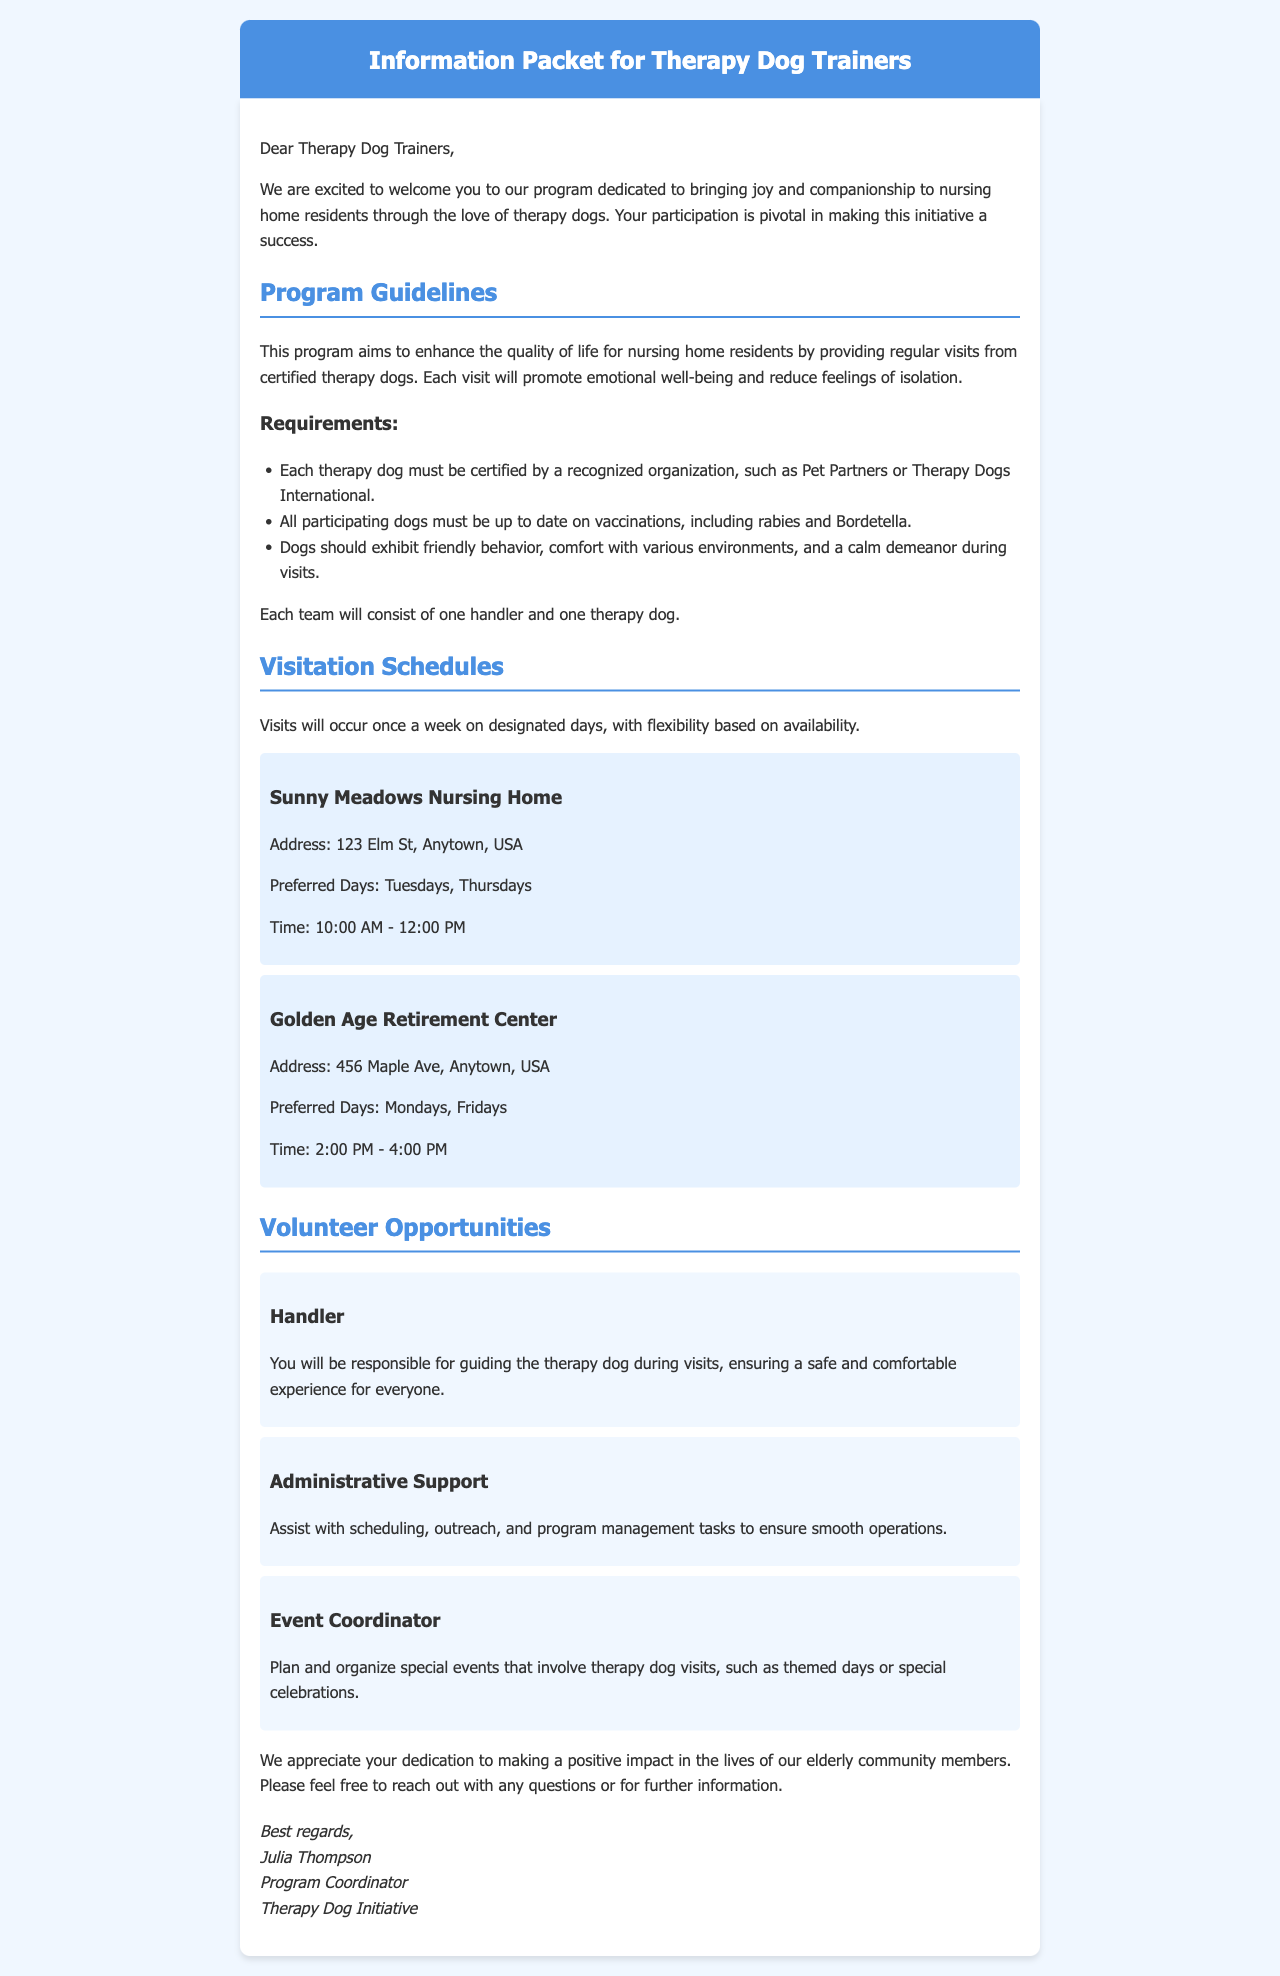what are the preferred days for Sunny Meadows Nursing Home? The document states that the preferred days for Sunny Meadows Nursing Home visits are Tuesdays and Thursdays.
Answer: Tuesdays, Thursdays how often will therapy dog visits occur? According to the document, visits will occur once a week.
Answer: once a week who is the Program Coordinator? The document lists Julia Thompson as the Program Coordinator of the Therapy Dog Initiative.
Answer: Julia Thompson what is a requirement for therapy dogs? A requirement mentioned in the document is that each therapy dog must be certified by a recognized organization.
Answer: certified by a recognized organization what times are the visits for Golden Age Retirement Center? The document specifies that visits for Golden Age Retirement Center are from 2:00 PM to 4:00 PM.
Answer: 2:00 PM - 4:00 PM what role is responsible for guiding the therapy dog during visits? The document states that the Handler is responsible for guiding the therapy dog during visits.
Answer: Handler which organization provides certification for therapy dogs? The document mentions organizations such as Pet Partners or Therapy Dogs International for certification.
Answer: Pet Partners or Therapy Dogs International what is one of the volunteer opportunities available? The document lists Handler, Administrative Support, and Event Coordinator as volunteer opportunities.
Answer: Handler why is the program important? The program is important to enhance the quality of life for nursing home residents by providing companionship through therapy dogs.
Answer: enhance quality of life 